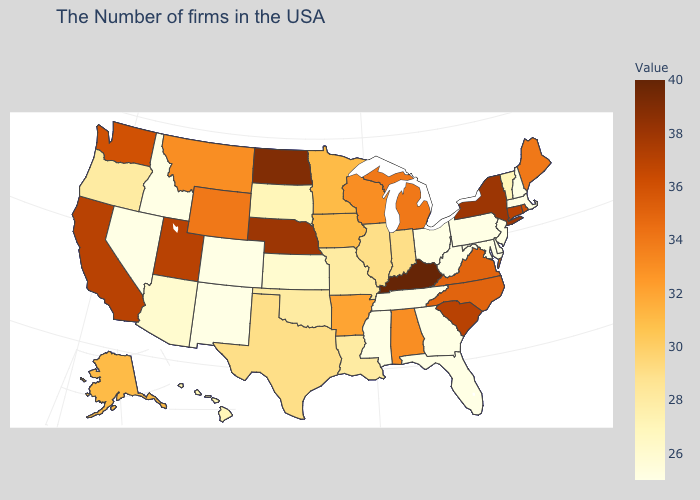Which states have the lowest value in the South?
Write a very short answer. Delaware, Maryland, West Virginia, Florida, Georgia, Tennessee, Mississippi. Does Illinois have a lower value than Michigan?
Short answer required. Yes. Which states have the highest value in the USA?
Keep it brief. Kentucky. Which states hav the highest value in the Northeast?
Answer briefly. New York. Is the legend a continuous bar?
Give a very brief answer. Yes. 